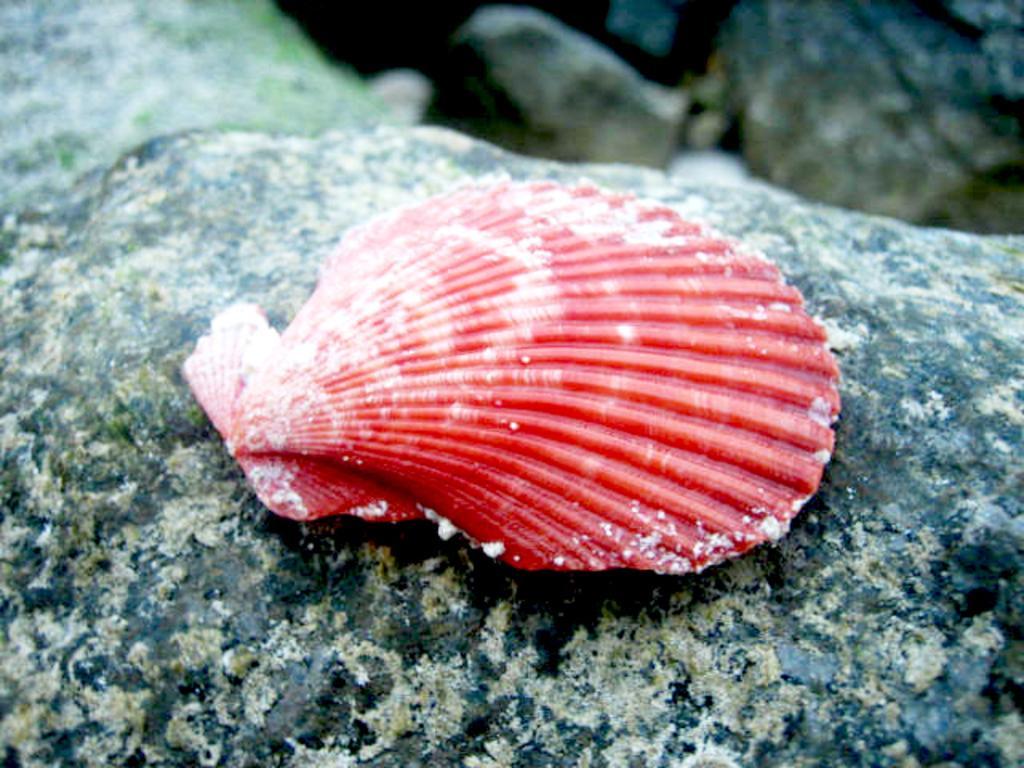Can you describe this image briefly? In the image there is a shell on the rock surface and the background of the rock is blur. 